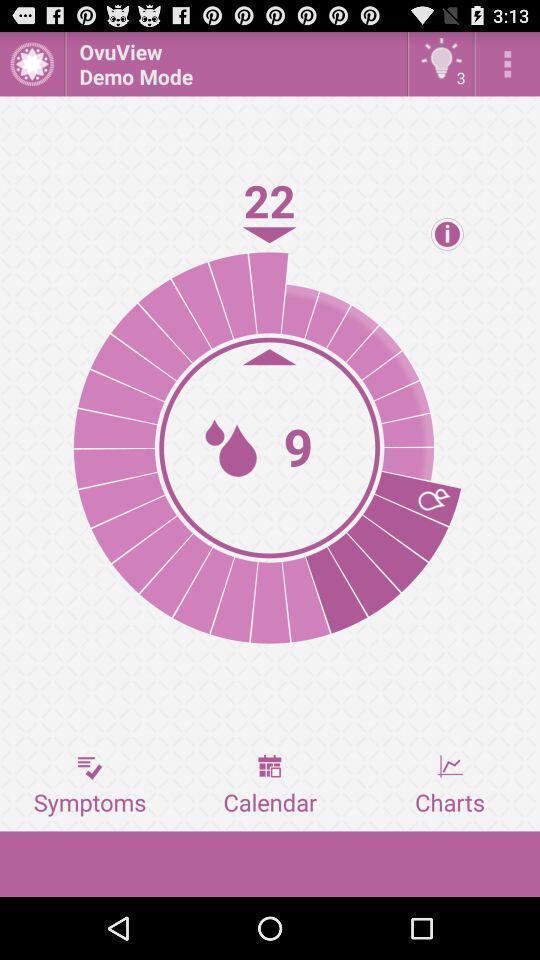Explain what's happening in this screen capture. Screen showing various options. 